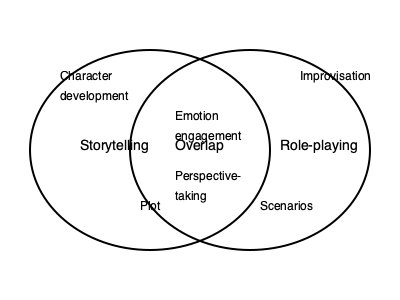Design a Venn diagram that illustrates the overlap between storytelling elements and role-playing techniques in training. Identify at least three elements that are unique to each domain and three elements that overlap. How can this visual representation enhance the design of interactive training workshops? To design an effective Venn diagram showcasing the overlap between storytelling and role-playing in training, follow these steps:

1. Identify unique elements for storytelling:
   - Character development
   - Plot structure
   - Narrative arc

2. Identify unique elements for role-playing:
   - Improvisation
   - Physical embodiment
   - Scenario-based learning

3. Determine overlapping elements:
   - Emotion engagement
   - Perspective-taking
   - Conflict resolution

4. Create the Venn diagram:
   - Draw two intersecting circles
   - Label one circle "Storytelling" and the other "Role-playing"
   - Place unique elements in their respective circles
   - Place overlapping elements in the intersection

5. Analyze how this visual representation enhances workshop design:
   a. Clarity: The diagram provides a clear overview of the relationship between storytelling and role-playing.
   b. Integration: It highlights areas where techniques from both domains can be combined for more effective training.
   c. Customization: Trainers can focus on specific elements based on workshop objectives.
   d. Creativity: The visual representation inspires new ideas for combining techniques.
   e. Balance: It ensures a well-rounded approach by incorporating elements from both domains.

6. Apply the insights to workshop design:
   - Develop activities that combine storytelling and role-playing elements
   - Create scenarios that incorporate character development and improvisation
   - Design exercises that focus on emotion engagement and perspective-taking
   - Use the overlapping elements to bridge the gap between storytelling and role-playing techniques

By utilizing this Venn diagram, trainers can create more engaging, comprehensive, and effective workshops that leverage the strengths of both storytelling and role-playing methodologies.
Answer: The Venn diagram enhances workshop design by providing clarity, promoting integration of techniques, enabling customization, inspiring creativity, and ensuring a balanced approach to combining storytelling and role-playing elements in training. 